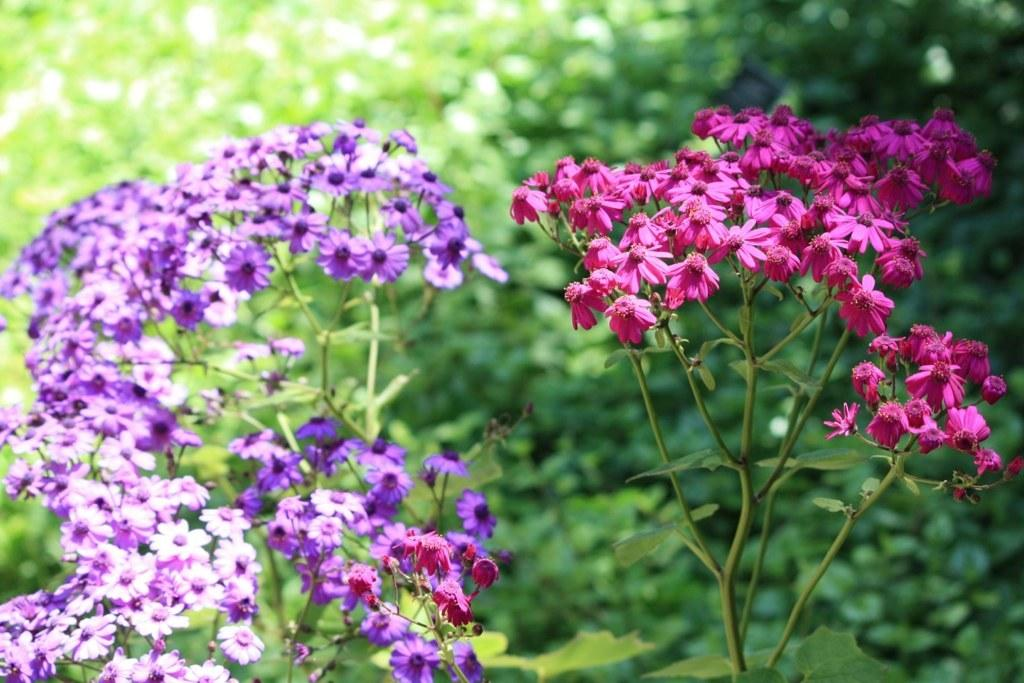What colors are the flowers on the plants in the image? The flowers on the plants are pink and purple. Can you describe the background of the image? The background of the image is blurry. What type of respect can be seen in the image? There is no indication of respect in the image, as it features flowers on plants and a blurry background. Can you tell me how many trains are visible in the image? There are no trains present in the image. 